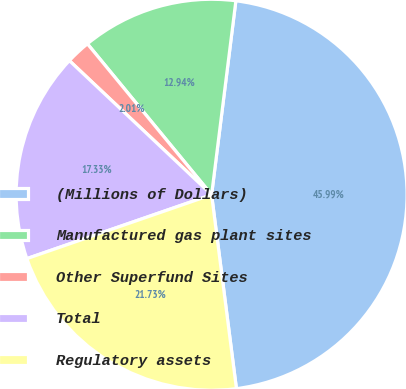Convert chart. <chart><loc_0><loc_0><loc_500><loc_500><pie_chart><fcel>(Millions of Dollars)<fcel>Manufactured gas plant sites<fcel>Other Superfund Sites<fcel>Total<fcel>Regulatory assets<nl><fcel>45.99%<fcel>12.94%<fcel>2.01%<fcel>17.33%<fcel>21.73%<nl></chart> 